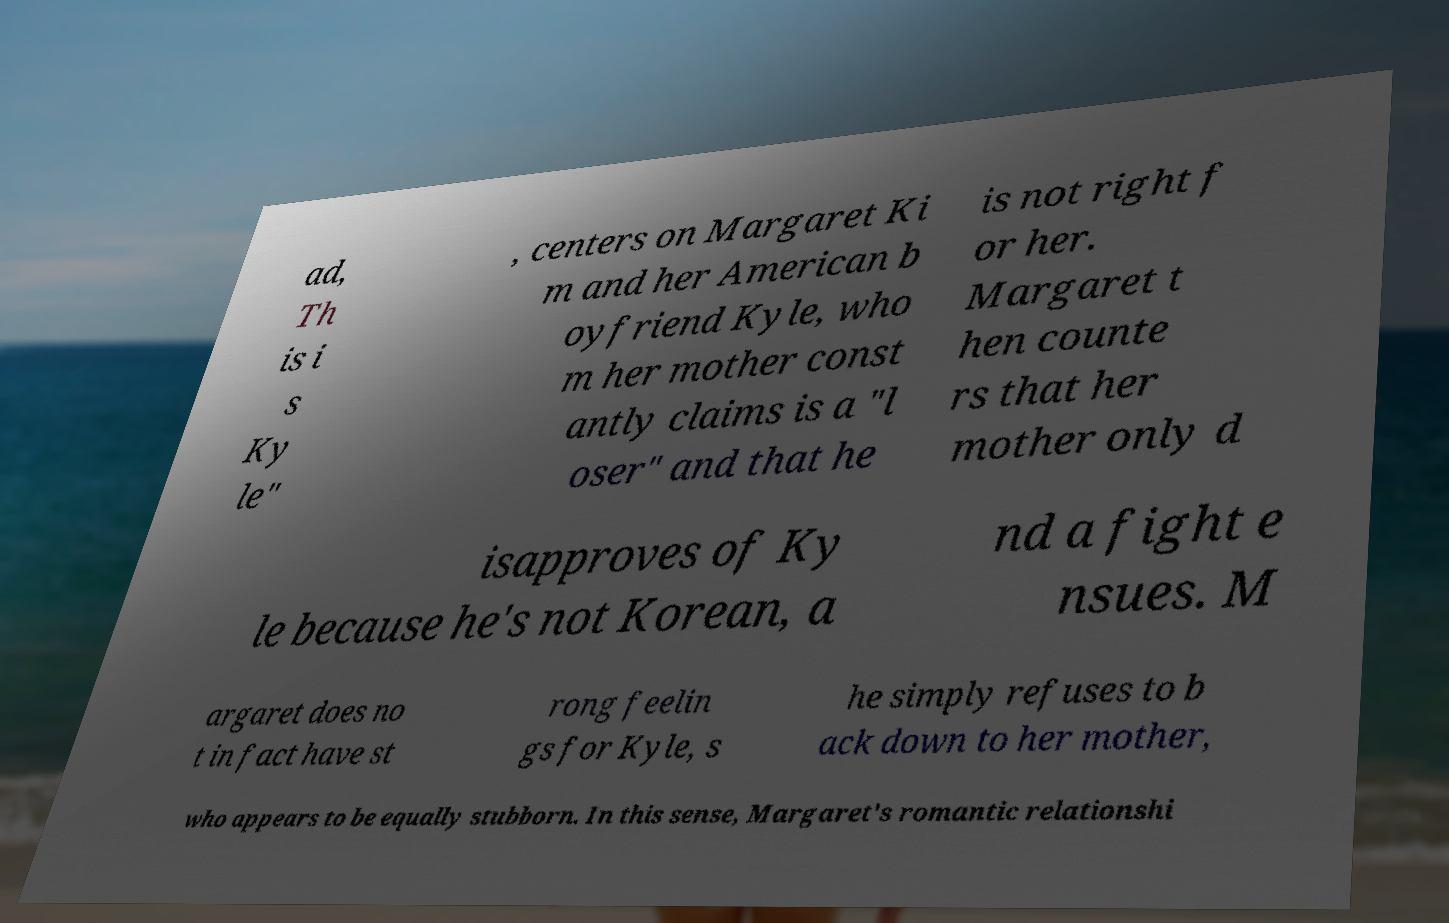Could you assist in decoding the text presented in this image and type it out clearly? ad, Th is i s Ky le" , centers on Margaret Ki m and her American b oyfriend Kyle, who m her mother const antly claims is a "l oser" and that he is not right f or her. Margaret t hen counte rs that her mother only d isapproves of Ky le because he's not Korean, a nd a fight e nsues. M argaret does no t in fact have st rong feelin gs for Kyle, s he simply refuses to b ack down to her mother, who appears to be equally stubborn. In this sense, Margaret's romantic relationshi 